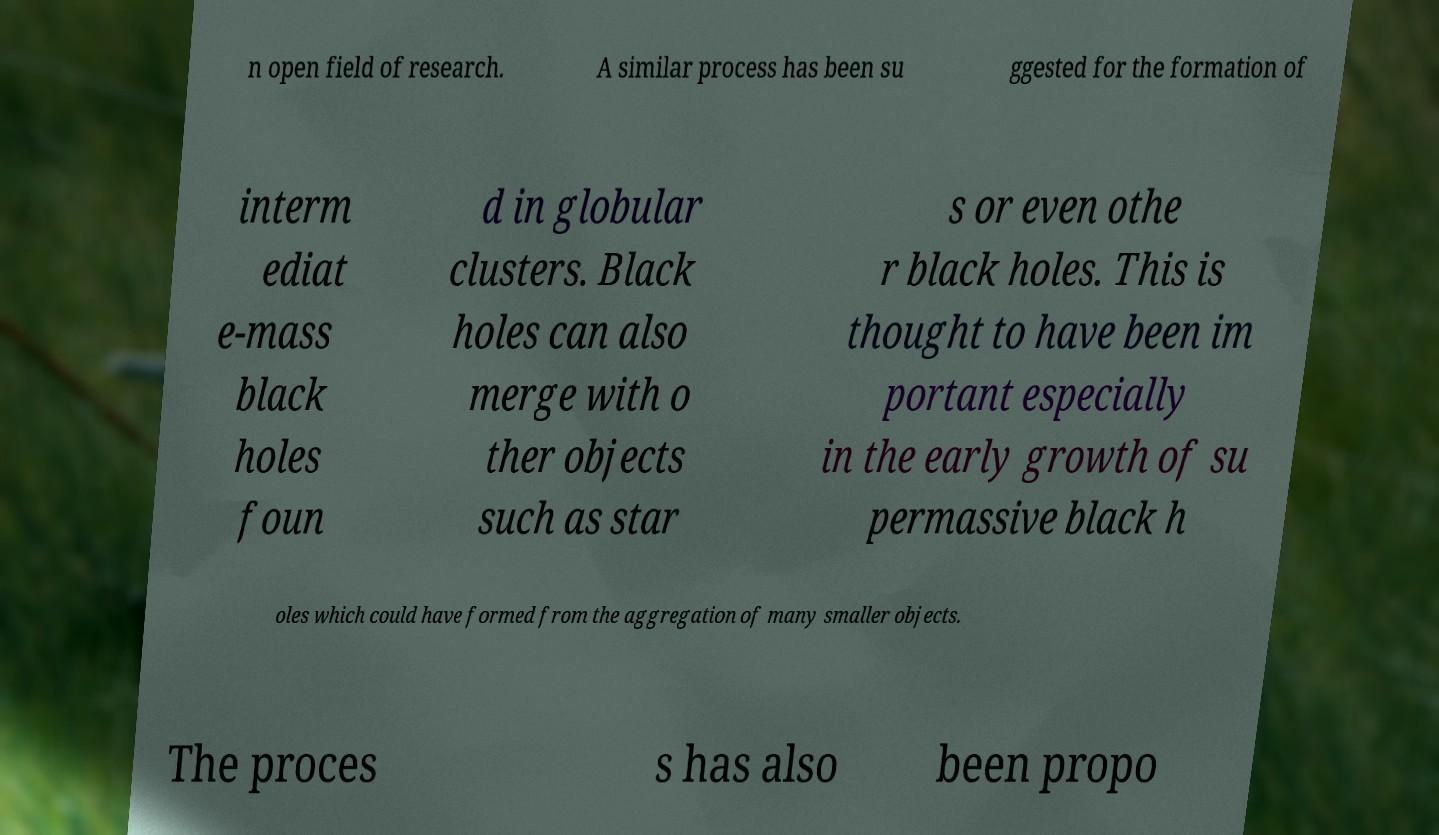Can you accurately transcribe the text from the provided image for me? n open field of research. A similar process has been su ggested for the formation of interm ediat e-mass black holes foun d in globular clusters. Black holes can also merge with o ther objects such as star s or even othe r black holes. This is thought to have been im portant especially in the early growth of su permassive black h oles which could have formed from the aggregation of many smaller objects. The proces s has also been propo 